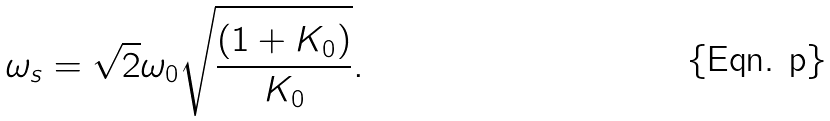Convert formula to latex. <formula><loc_0><loc_0><loc_500><loc_500>\omega _ { s } = \sqrt { 2 } \omega _ { 0 } \sqrt { \frac { ( 1 + K _ { 0 } ) } { K _ { 0 } } } .</formula> 